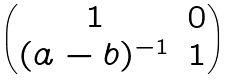<formula> <loc_0><loc_0><loc_500><loc_500>\begin{pmatrix} 1 & 0 \\ ( a - b ) ^ { - 1 } & 1 \end{pmatrix}</formula> 